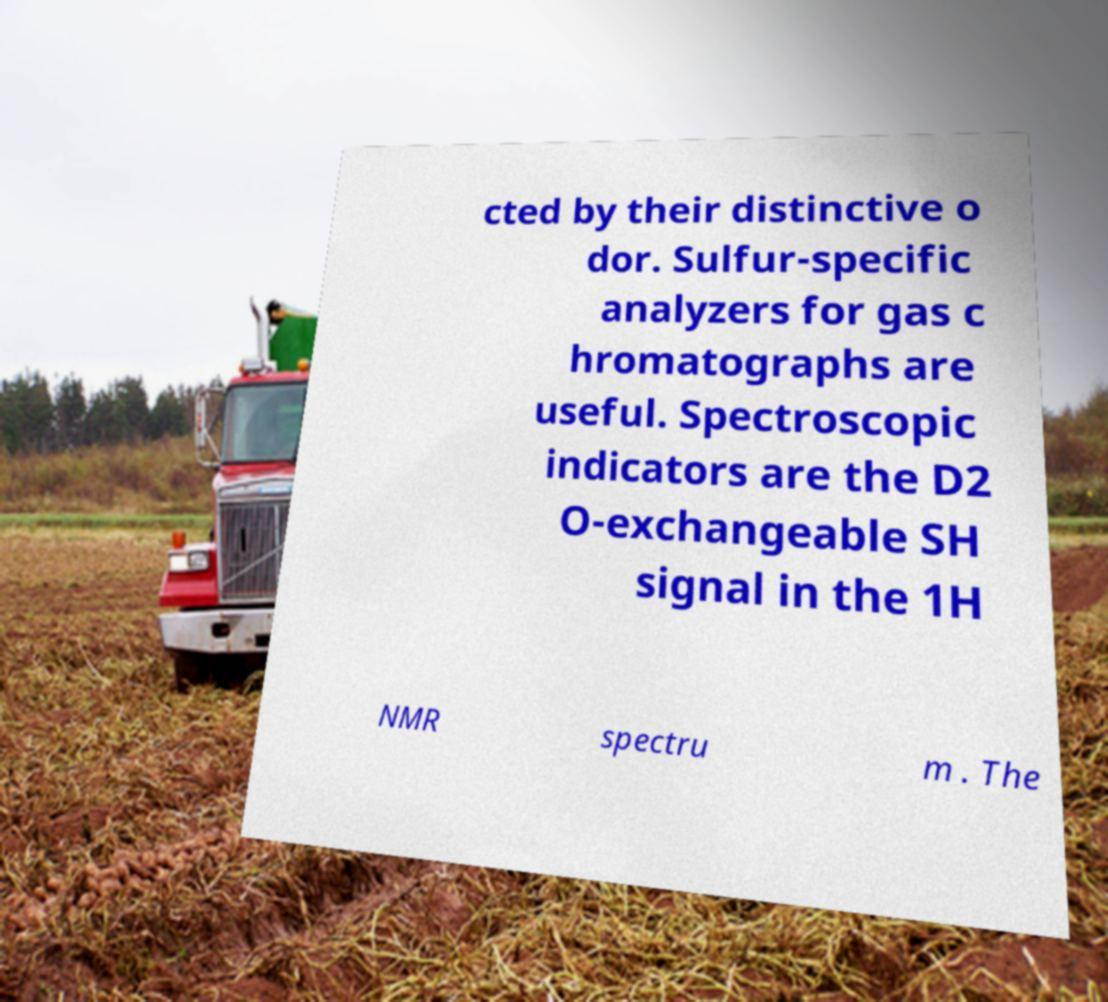I need the written content from this picture converted into text. Can you do that? cted by their distinctive o dor. Sulfur-specific analyzers for gas c hromatographs are useful. Spectroscopic indicators are the D2 O-exchangeable SH signal in the 1H NMR spectru m . The 